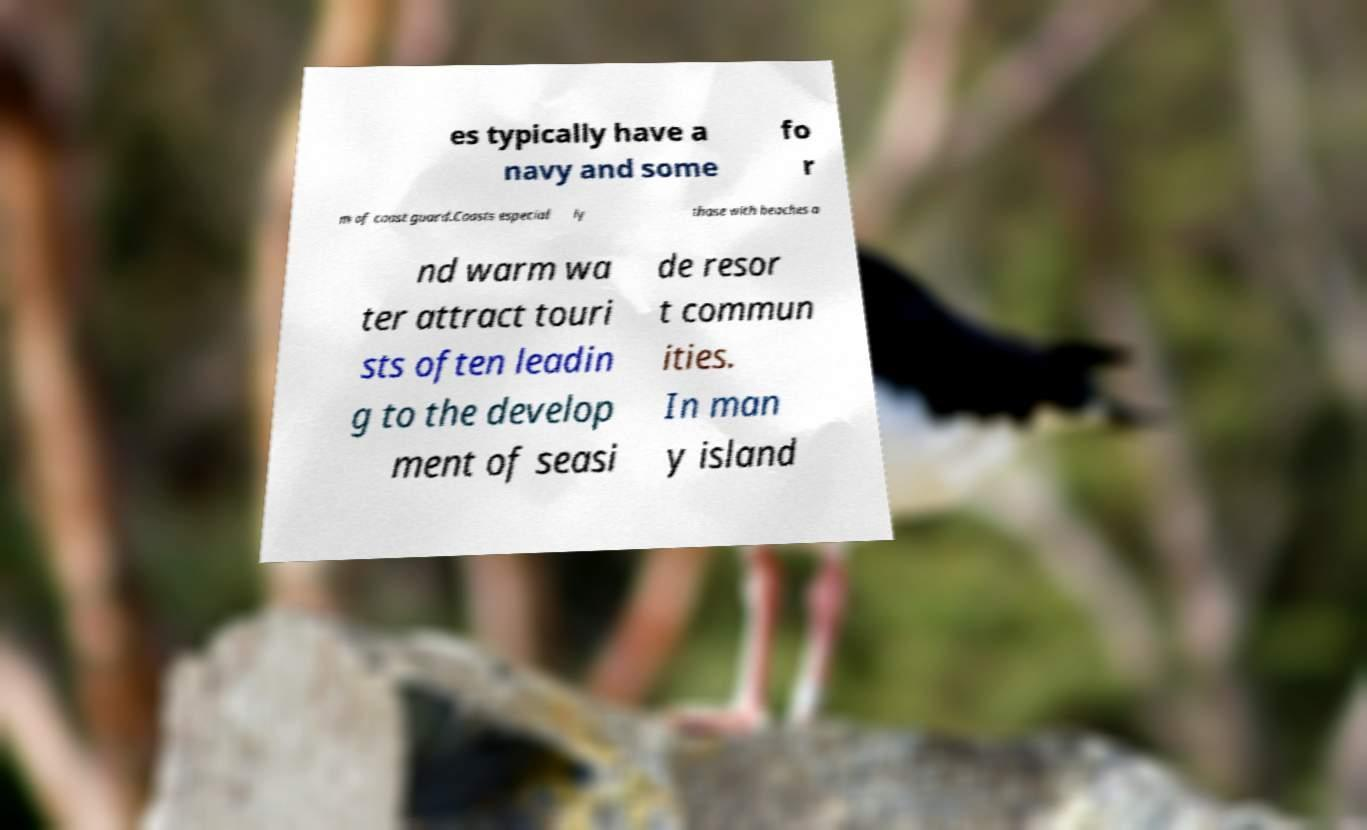Please identify and transcribe the text found in this image. es typically have a navy and some fo r m of coast guard.Coasts especial ly those with beaches a nd warm wa ter attract touri sts often leadin g to the develop ment of seasi de resor t commun ities. In man y island 